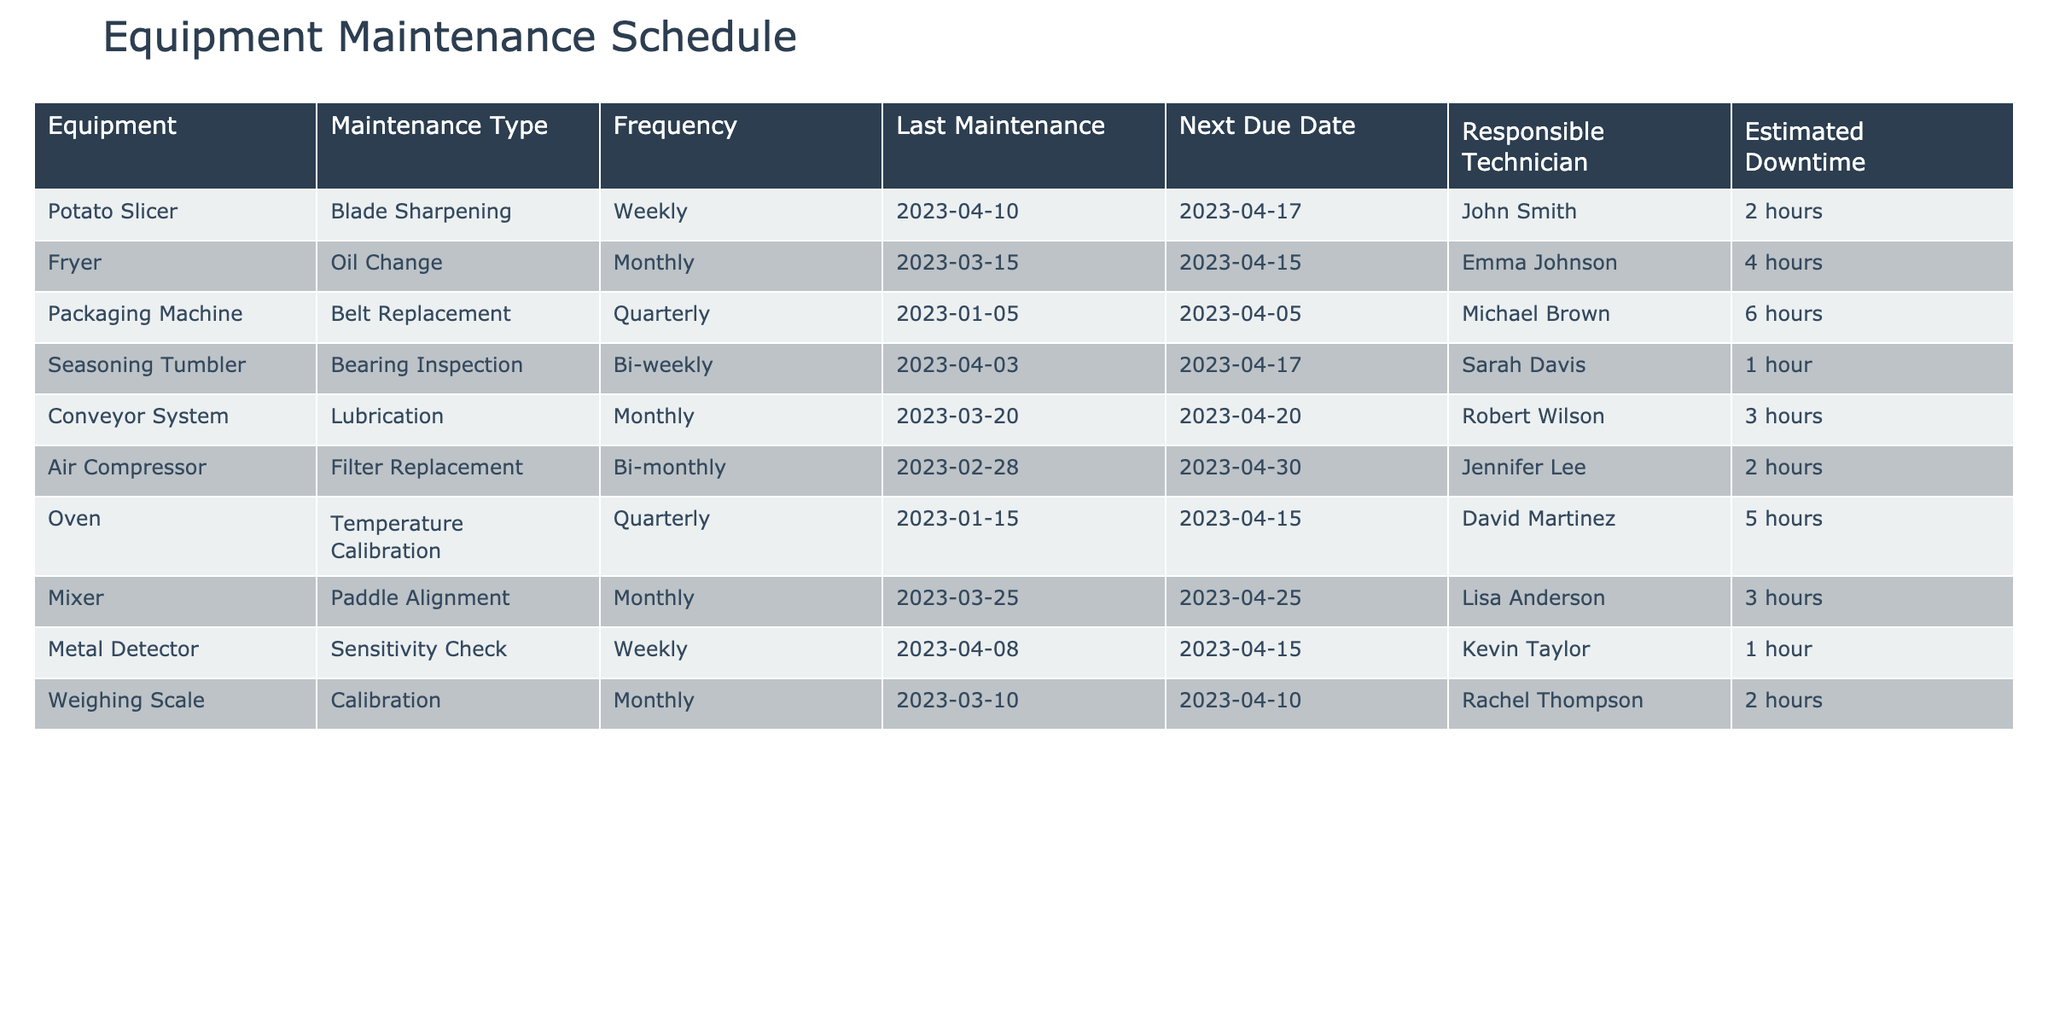What is the estimated downtime for the Fryer during its next maintenance? The table indicates that the estimated downtime for the Fryer, which is scheduled for its next maintenance on April 15, 2023, is 4 hours.
Answer: 4 hours Which piece of equipment has the next due maintenance date on April 17, 2023? The equipment with the next due maintenance on April 17, 2023, is the Potato Slicer.
Answer: Potato Slicer Is the air compressor maintenance type bi-monthly? According to the table, the maintenance type for the Air Compressor is indeed bi-monthly.
Answer: Yes How many hours of downtime are expected in total for the maintenance scheduled for April 2023? The total estimated downtime for the maintenance in April includes 2 hours (Potato Slicer) + 4 hours (Fryer) + 3 hours (Conveyor System) + 2 hours (Weighing Scale) + 3 hours (Mixer) = 14 hours.
Answer: 14 hours What maintenance type is performed bi-weekly? The maintenance type that is performed bi-weekly is Bearing Inspection for the Seasoning Tumbler.
Answer: Bearing Inspection Which equipment requires calibration, and when was its last maintenance performed? The equipment that requires calibration is the Weighing Scale, with the last maintenance performed on March 10, 2023.
Answer: Weighing Scale, March 10, 2023 How frequently is the Conveyor System maintained, and when was its last service? The Conveyor System is maintained monthly, with its last service on March 20, 2023.
Answer: Monthly, March 20, 2023 What is the average downtime of all equipment listed in the maintenance schedule? To find the average downtime, we sum the estimated downtimes (2 + 4 + 6 + 1 + 3 + 2 + 5 + 3 + 1 + 2 = 29) and divide by the number of equipment (10). So, the average is 29 hours / 10 = 2.9 hours.
Answer: 2.9 hours Which equipment has the longest estimated downtime during its maintenance? The equipment with the longest estimated downtime is the Packaging Machine, having 6 hours needed for its Belt Replacement.
Answer: Packaging Machine How many different maintenance types are there, according to the table? The different maintenance types listed in the table are Blade Sharpening, Oil Change, Belt Replacement, Bearing Inspection, Lubrication, Filter Replacement, Temperature Calibration, Paddle Alignment, Sensitivity Check, and Calibration, making it a total of 10 unique types.
Answer: 10 